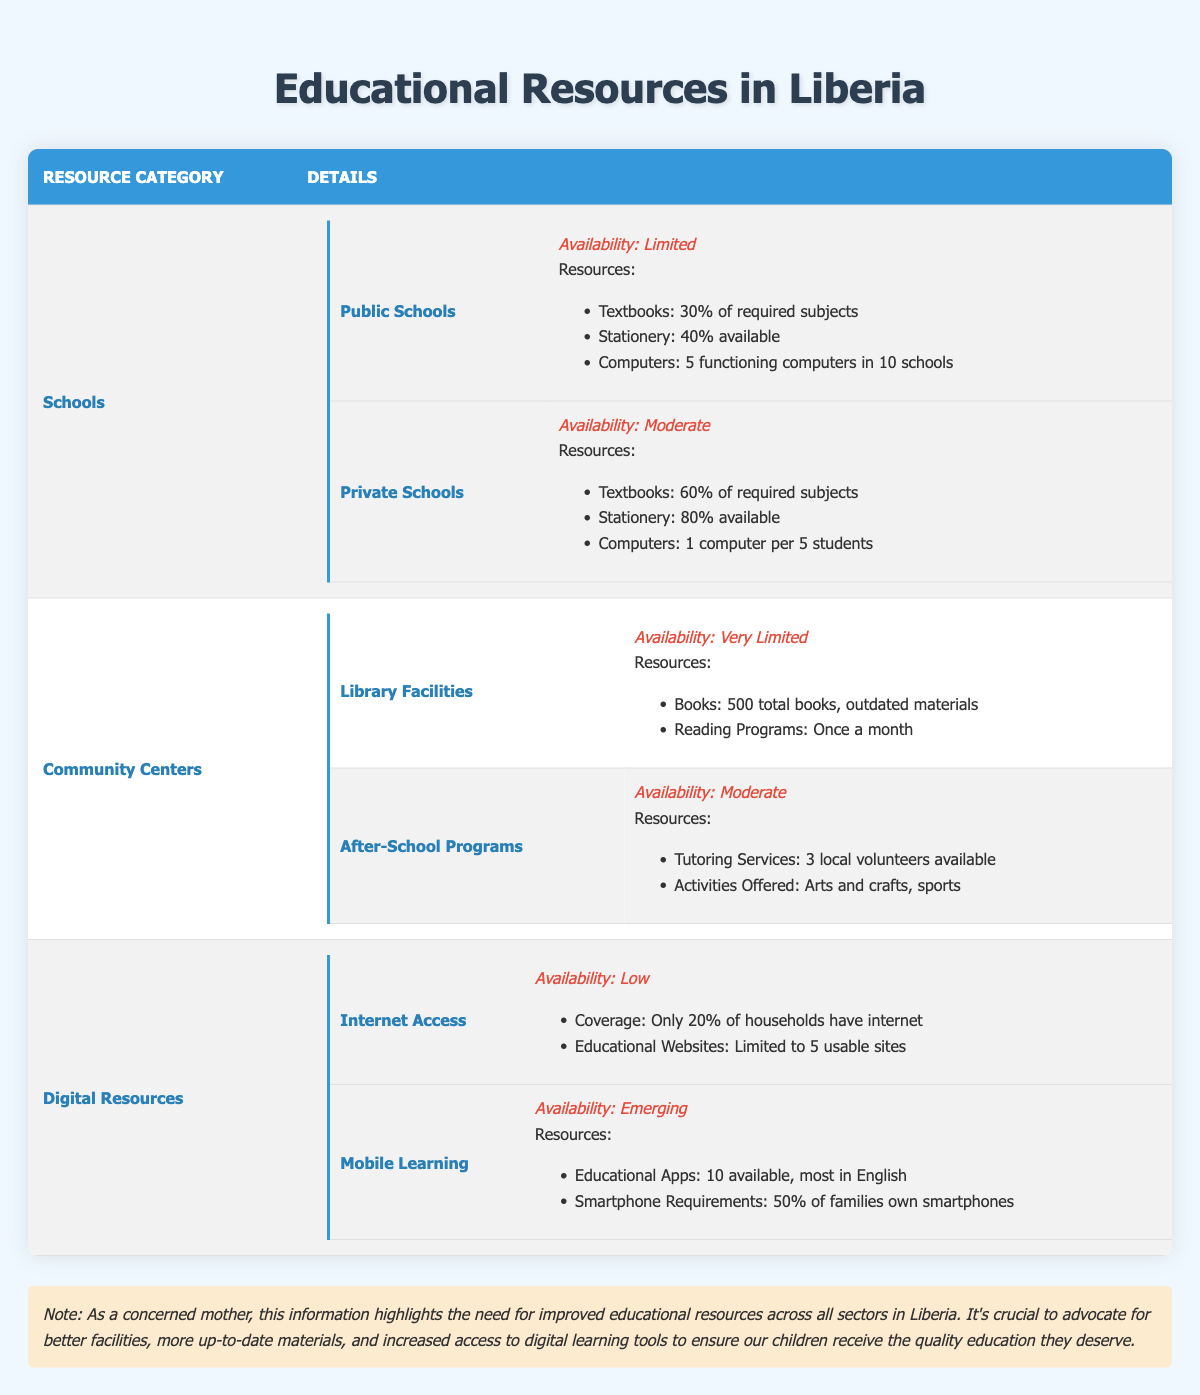What is the availability of resources in public schools? The table states that the availability of resources in public schools is "Limited."
Answer: Limited How many functioning computers are available in public schools? According to the data, there are "5 functioning computers in 10 schools."
Answer: 5 functioning computers What percentage of required subjects do private schools provide textbooks for? From the table, private schools provide textbooks for "60% of required subjects."
Answer: 60% Is the availability of internet access high in local communities? The table indicates that the availability of internet access is "Low."
Answer: No What is the difference in textbook availability between public and private schools? Public schools have textbooks for "30% of required subjects," while private schools have textbooks for "60% of required subjects." The difference is 60 - 30 = 30%.
Answer: 30% How often do reading programs occur in community library facilities? The table shows that reading programs occur "Once a month" within the library facilities.
Answer: Once a month Considering the percentage of households with internet access, what percentage of households lack internet? It states that "Only 20% of households have internet," so 100% - 20% = 80% of households lack internet access.
Answer: 80% What activities are offered in after-school programs? The table lists activities such as "Arts and crafts, sports" being offered in after-school programs.
Answer: Arts and crafts, sports What is the combined availability category of Community Centers resources? Community Centers consist of two segments: Library Facilities and After-School Programs, with availability being "Very Limited" for Library Facilities and "Moderate" for After-School Programs. Thus, the overall availability can be considered "Moderate" due to the broader reach of after-school support.
Answer: Moderate How many educational apps are available for mobile learning? The data specifies that there are "10 available educational apps" related to mobile learning.
Answer: 10 